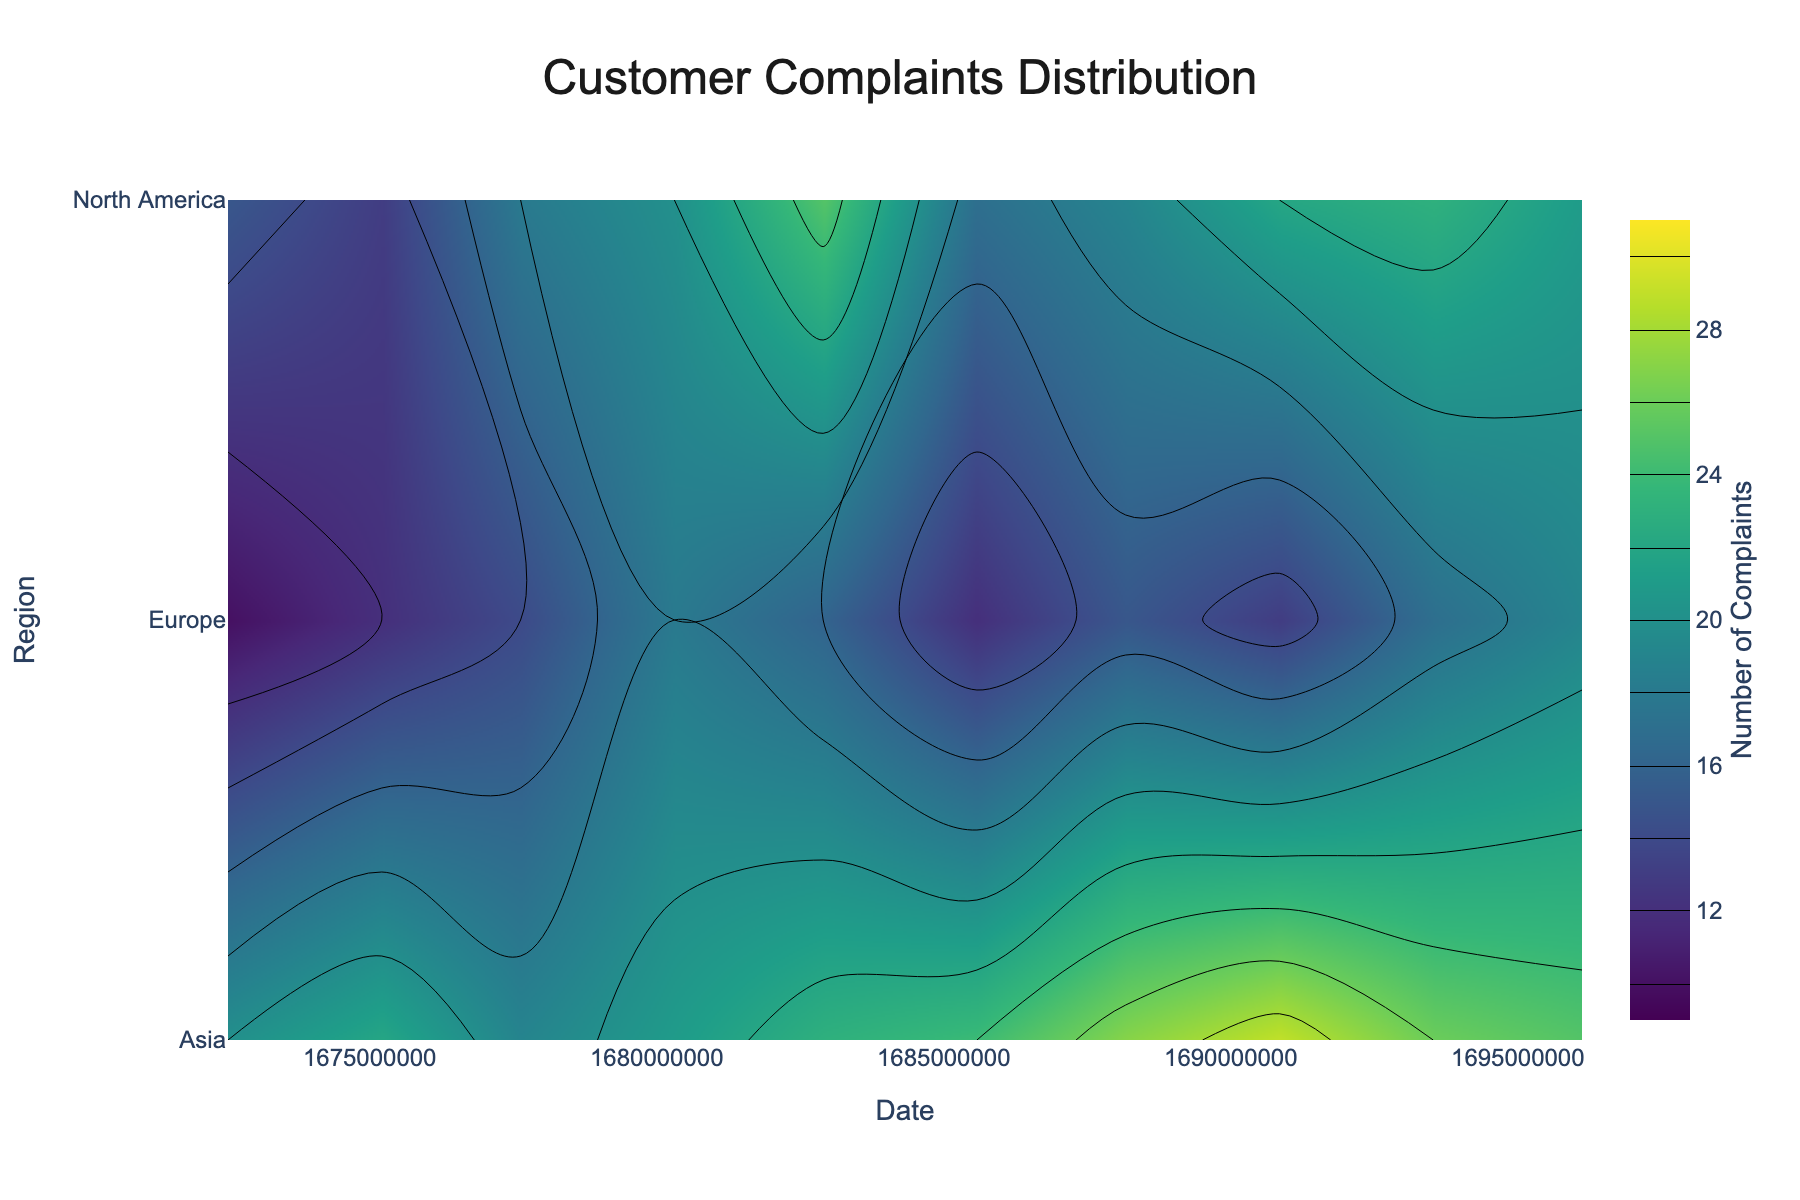What's the title of the plot? The title is displayed at the top of the figure, and it sets the context of the visualization. Here, it says "Customer Complaints Distribution".
Answer: Customer Complaints Distribution What regions are displayed on the y-axis? The regions displayed on the y-axis are labeled alongside the plot and include various parts of the world represented in the data.
Answer: North America, Europe, Asia Which month had the highest number of complaints in Asia? Look at the contour plot for the region labeled 'Asia' and find the month with the most intense color indicating the highest value.
Answer: August 2023 How does the number of complaints change in North America from January to October 2023? Track the color gradient and contour lines corresponding to 'North America' from January to October. It allows us to observe the shifts in density, showing fluctuations.
Answer: It generally increases with some drops Which region had the most complaints on September 1, 2023? Observe the contour levels for all regions on the date marked September 1, 2023, and identify the most intense colored region.
Answer: Asia What is the range of the number of complaints depicted in the color bar? The color bar on the right shows the range of complaints with the corresponding colors from minimum to maximum.
Answer: 10 to 30 Compare the trend of customer complaints in Europe and Asia over the months. Study the contour lines and colors representing 'Europe' and 'Asia' over the dates and compare the trends; this involves checking increases and decreases over time for each region.
Answer: Asia shows a generally increasing trend while Europe is more fluctuating What is the approximate number of complaints in Europe in June 2023? Locate June 2023 on the x-axis and follow vertically to the section for 'Europe,' then match the color intensity to the color bar to estimate the number of complaints.
Answer: Approximately 12 Which month shows the highest concentration of customer complaints for all regions combined? Identify the month with the darkest/intensely colored areas across all three regions in the contour plot.
Answer: July or August 2023 Is there a region that consistently shows fewer complaints compared to others? Trace through the contour levels for each region across all months and identify if any region consistently remains lighter, indicating fewer complaints.
Answer: Europe 